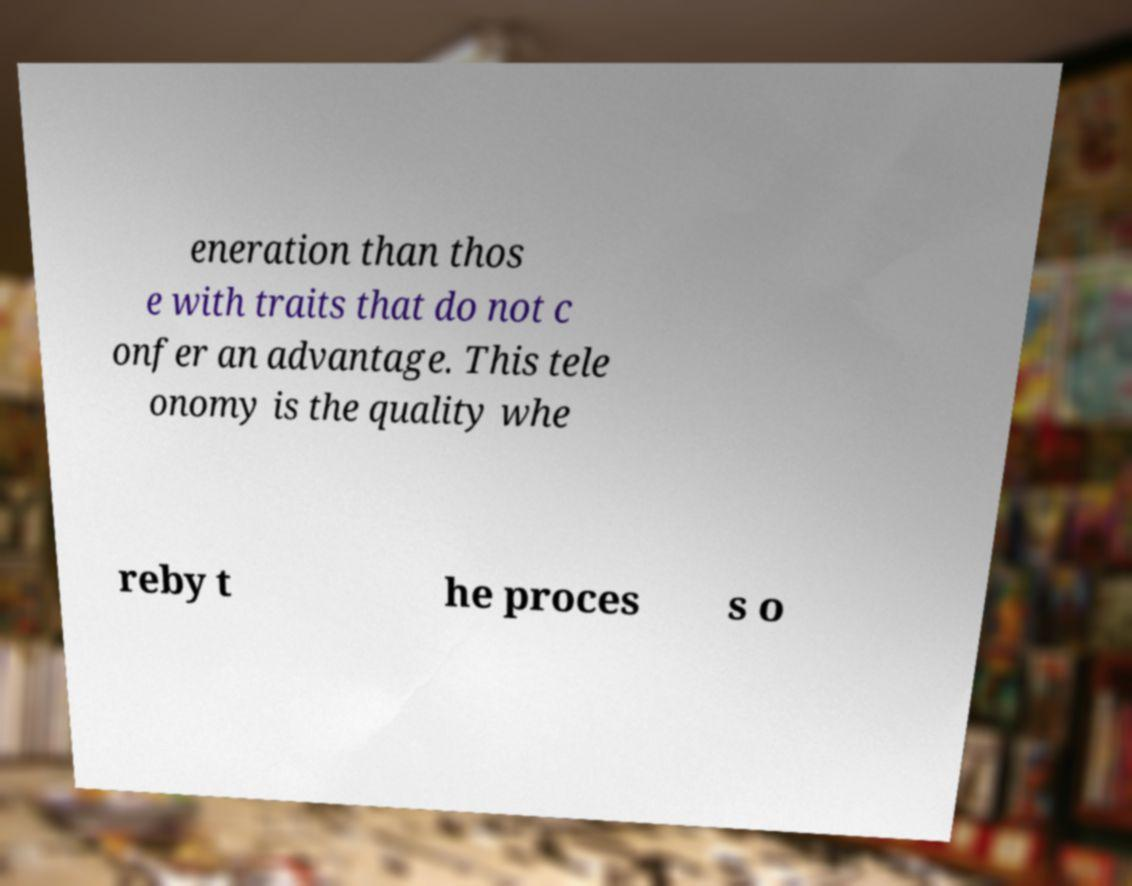Can you accurately transcribe the text from the provided image for me? eneration than thos e with traits that do not c onfer an advantage. This tele onomy is the quality whe reby t he proces s o 